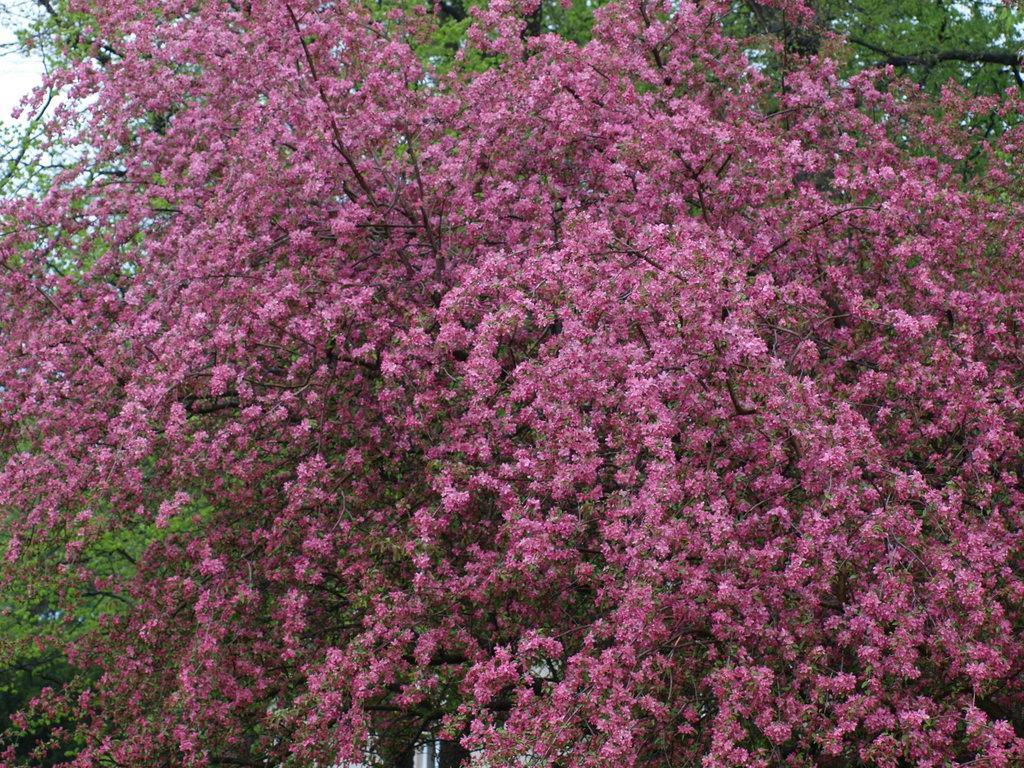How would you summarize this image in a sentence or two? In front of the image there is a tree with flowers. In the background there are trees with leaves.  